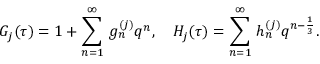<formula> <loc_0><loc_0><loc_500><loc_500>G _ { j } ( \tau ) = 1 + \sum _ { n = 1 } ^ { \infty } \, g _ { n } ^ { ( j ) } q ^ { n } , H _ { j } ( \tau ) = \sum _ { n = 1 } ^ { \infty } \, h _ { n } ^ { ( j ) } q ^ { n - \frac { 1 } { 3 } } .</formula> 